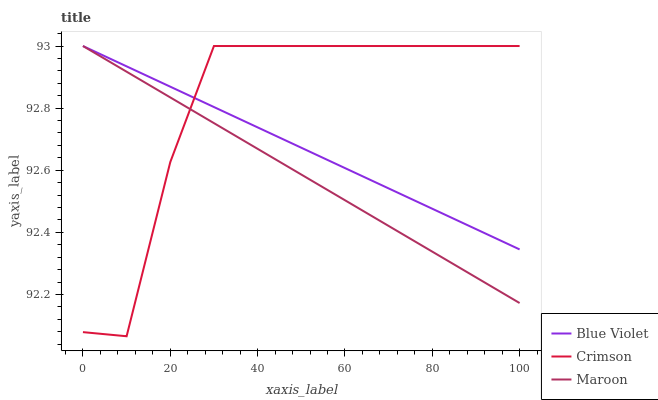Does Maroon have the minimum area under the curve?
Answer yes or no. Yes. Does Crimson have the maximum area under the curve?
Answer yes or no. Yes. Does Blue Violet have the minimum area under the curve?
Answer yes or no. No. Does Blue Violet have the maximum area under the curve?
Answer yes or no. No. Is Blue Violet the smoothest?
Answer yes or no. Yes. Is Crimson the roughest?
Answer yes or no. Yes. Is Maroon the smoothest?
Answer yes or no. No. Is Maroon the roughest?
Answer yes or no. No. Does Crimson have the lowest value?
Answer yes or no. Yes. Does Maroon have the lowest value?
Answer yes or no. No. Does Blue Violet have the highest value?
Answer yes or no. Yes. Does Crimson intersect Maroon?
Answer yes or no. Yes. Is Crimson less than Maroon?
Answer yes or no. No. Is Crimson greater than Maroon?
Answer yes or no. No. 